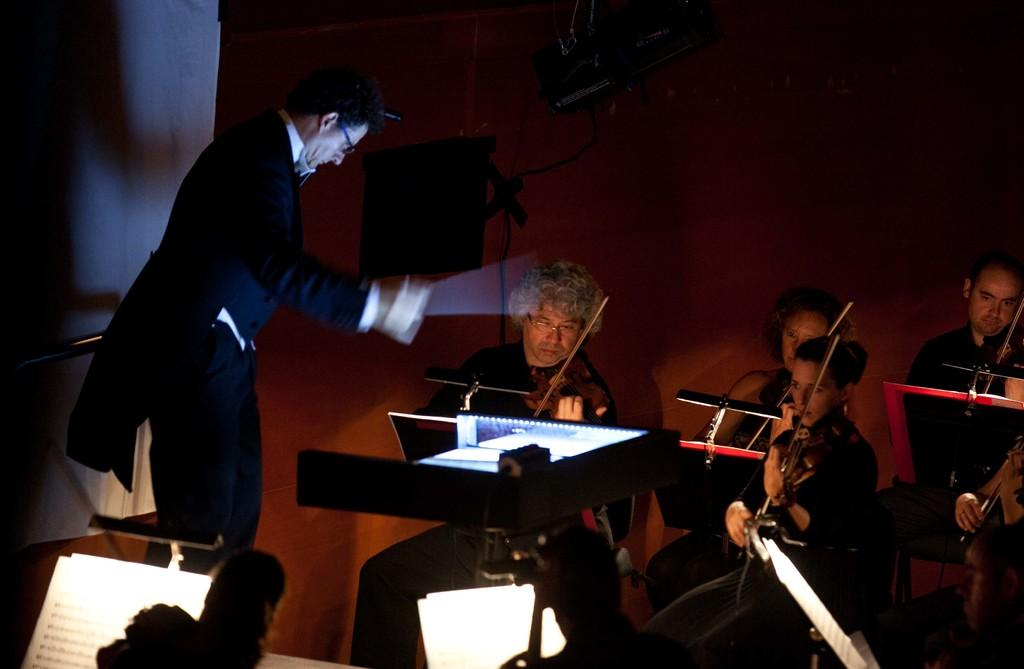Who is present in the image? There are people in the image. What are the people doing in the image? The people are sitting and holding musical instruments. Is there anyone standing in the image? Yes, there is a man standing in the image. How does the water flow around the island in the image? There is no water or island present in the image; it features people sitting and holding musical instruments, as well as a standing man. 